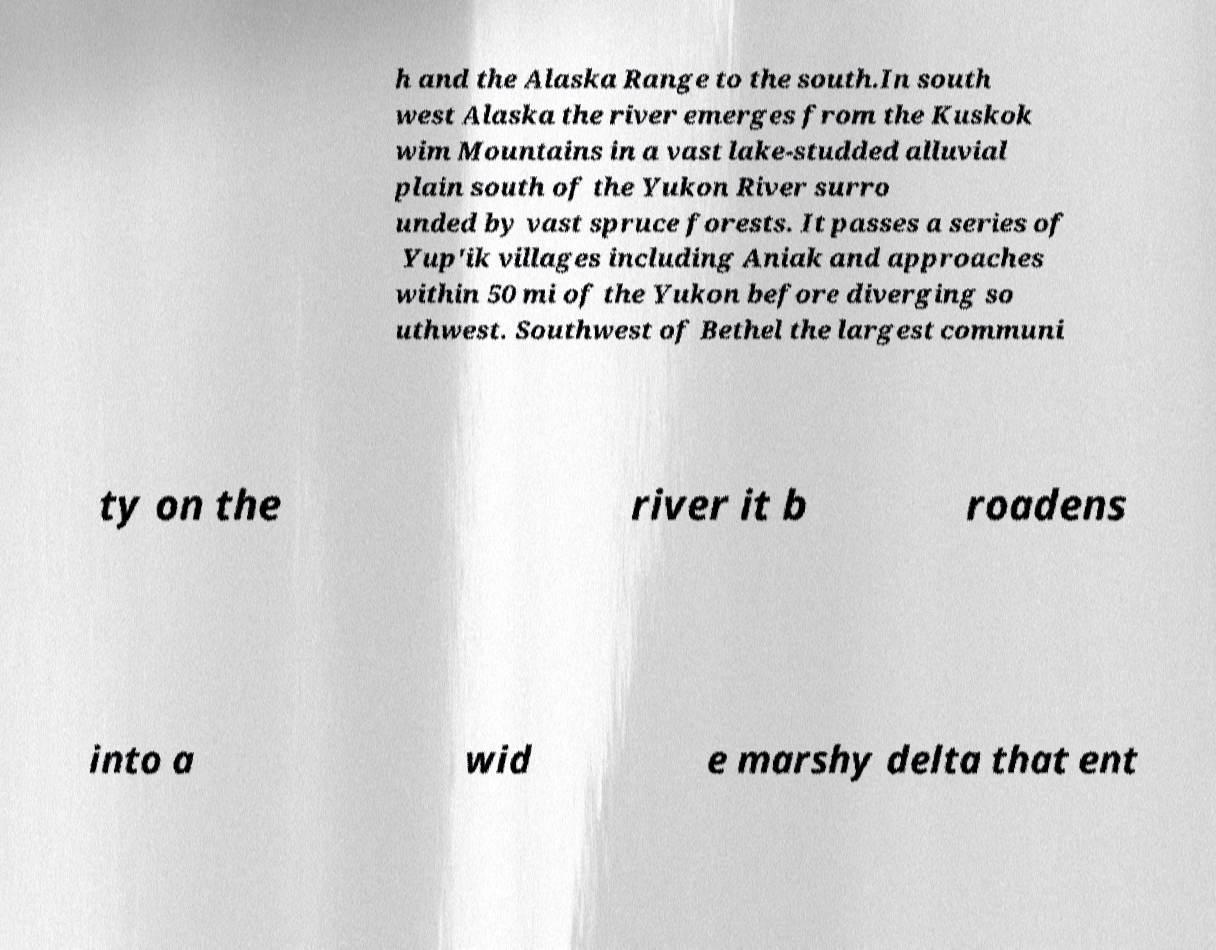Please identify and transcribe the text found in this image. h and the Alaska Range to the south.In south west Alaska the river emerges from the Kuskok wim Mountains in a vast lake-studded alluvial plain south of the Yukon River surro unded by vast spruce forests. It passes a series of Yup'ik villages including Aniak and approaches within 50 mi of the Yukon before diverging so uthwest. Southwest of Bethel the largest communi ty on the river it b roadens into a wid e marshy delta that ent 